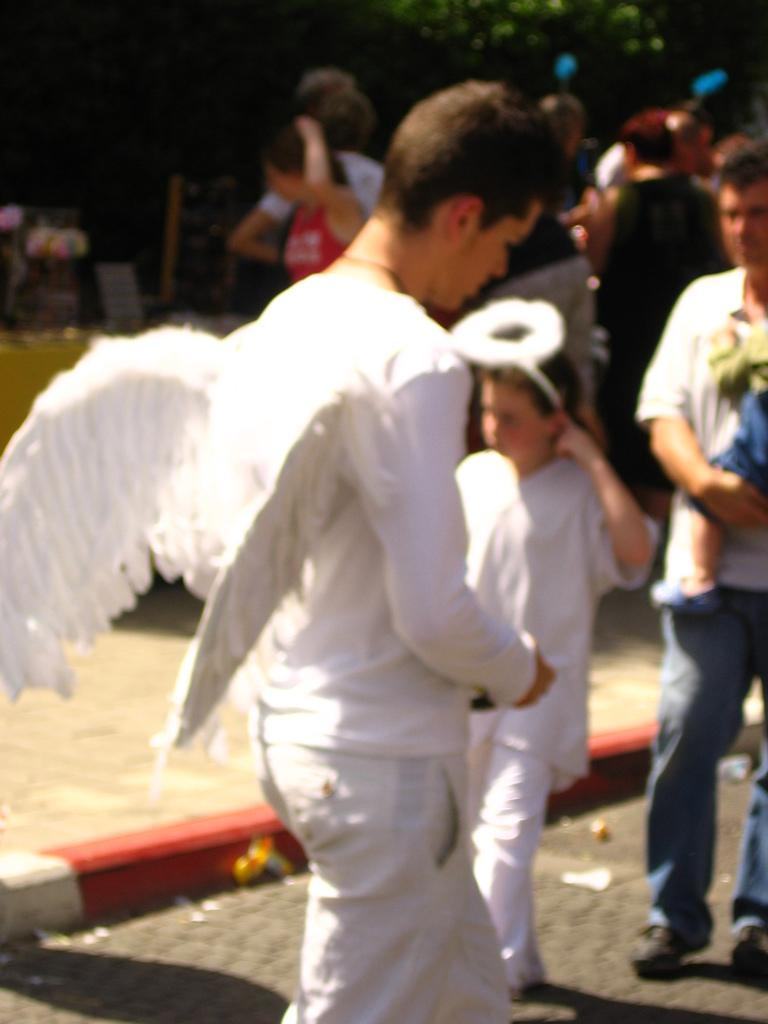What are the people in the image doing? The people in the image are standing and walking. Where are the people located in the image? The people are in the middle of the image. What can be seen in the background of the image? There are trees visible in the background of the image. What type of honey is being collected by the people in the image? There is no honey or honey collection activity present in the image. What is the tendency of the people in the image to move in a specific direction? The image does not provide information about the people's tendency to move in a specific direction. 